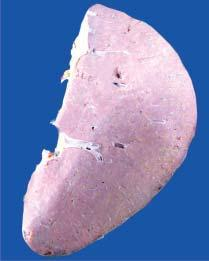does the sectioned surface show presence of plae waxy translucency in a map-like pattern?
Answer the question using a single word or phrase. Yes 